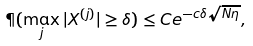Convert formula to latex. <formula><loc_0><loc_0><loc_500><loc_500>\P ( \max _ { j } | X ^ { ( j ) } | \geq \delta ) \leq C e ^ { - c \delta \sqrt { N \eta } } ,</formula> 